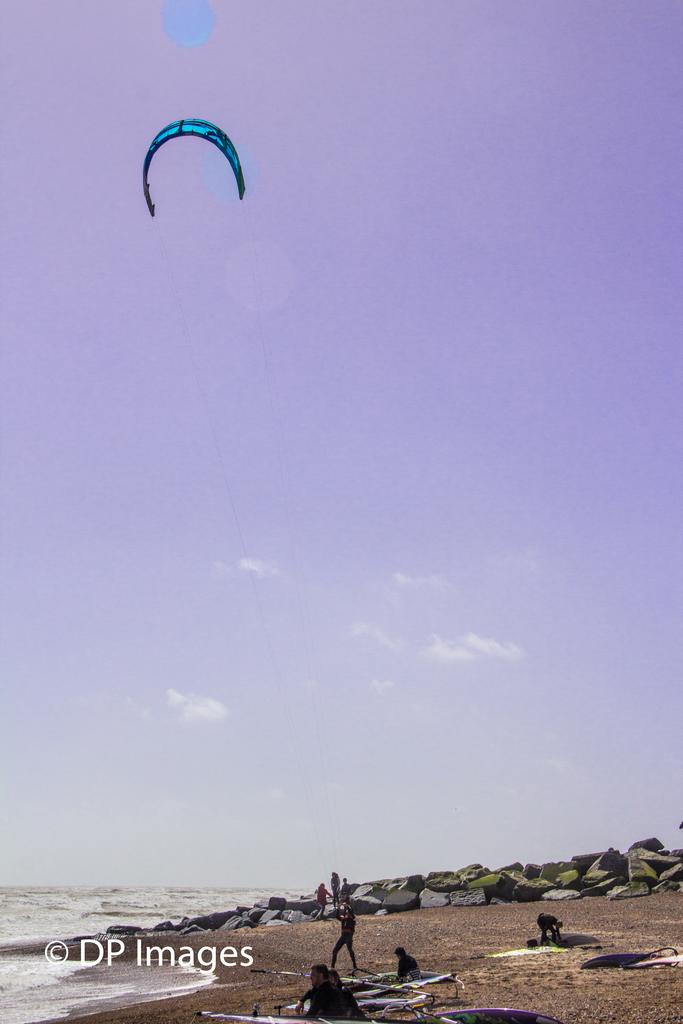How many people are in the image? There are people in the image, but the exact number is not specified. What is one person holding in the image? One person is holding a parachute in the image. What type of terrain can be seen in the image? There are rocks visible in the image, which suggests a rocky terrain. What natural element is visible in the image? There is water visible in the image, which could be a river, lake, or ocean. What is visible in the background of the image? The sky is visible in the image. What type of chalk is being used to draw on the rocks in the image? There is no chalk or drawing activity visible in the image. How much does the dime cost in the image? There is no mention of a dime or any currency in the image. 